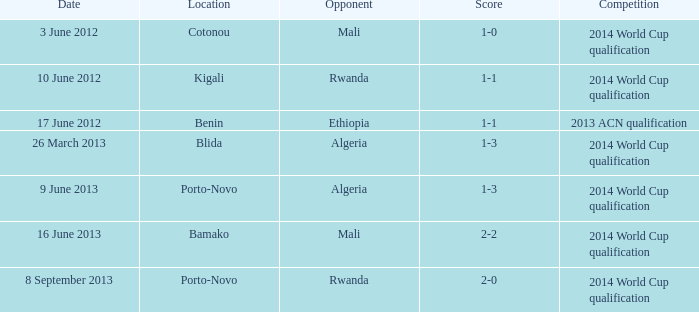What rivalry occurs in bamako? 2014 World Cup qualification. 